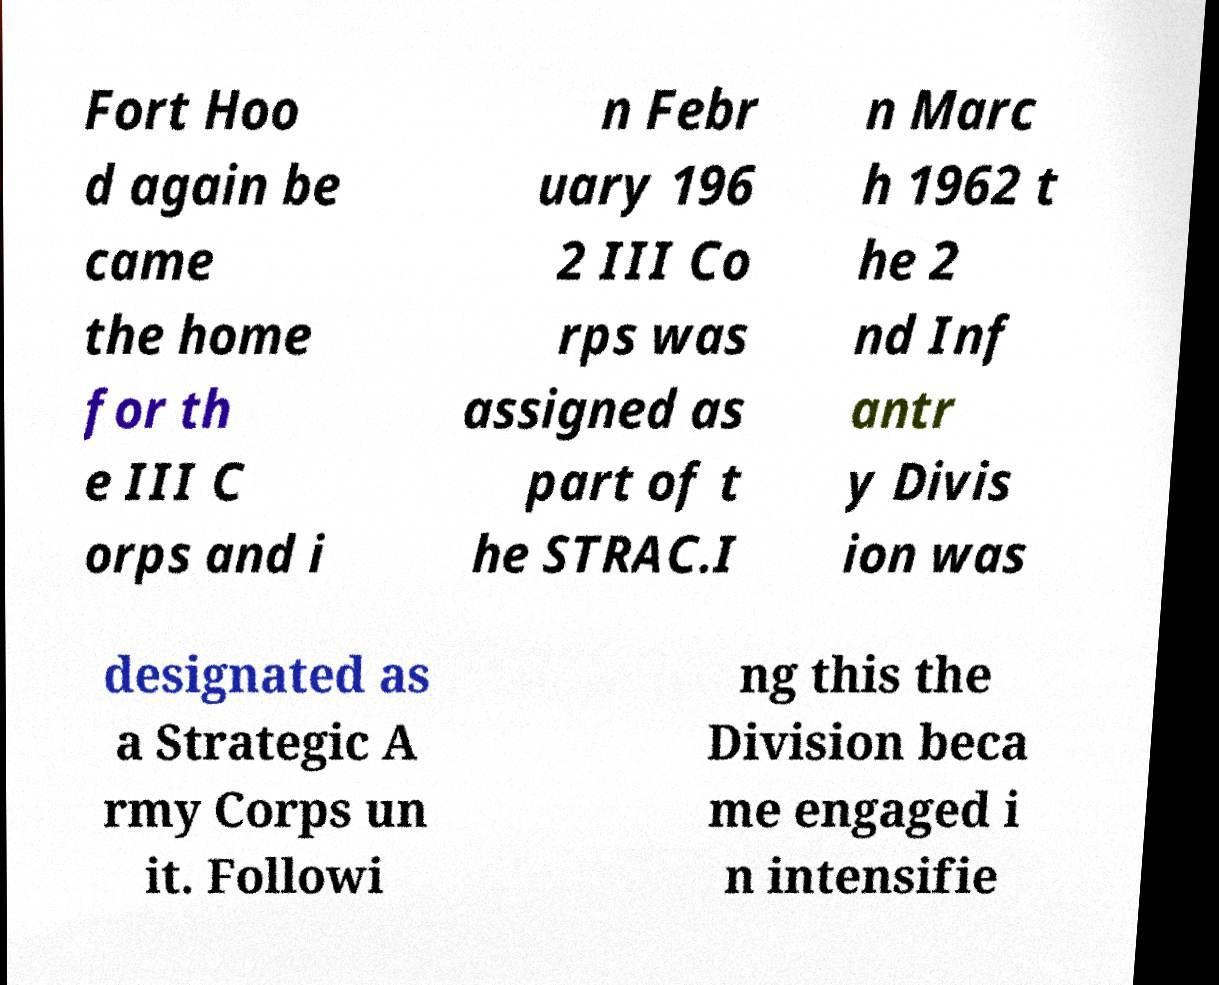Please identify and transcribe the text found in this image. Fort Hoo d again be came the home for th e III C orps and i n Febr uary 196 2 III Co rps was assigned as part of t he STRAC.I n Marc h 1962 t he 2 nd Inf antr y Divis ion was designated as a Strategic A rmy Corps un it. Followi ng this the Division beca me engaged i n intensifie 